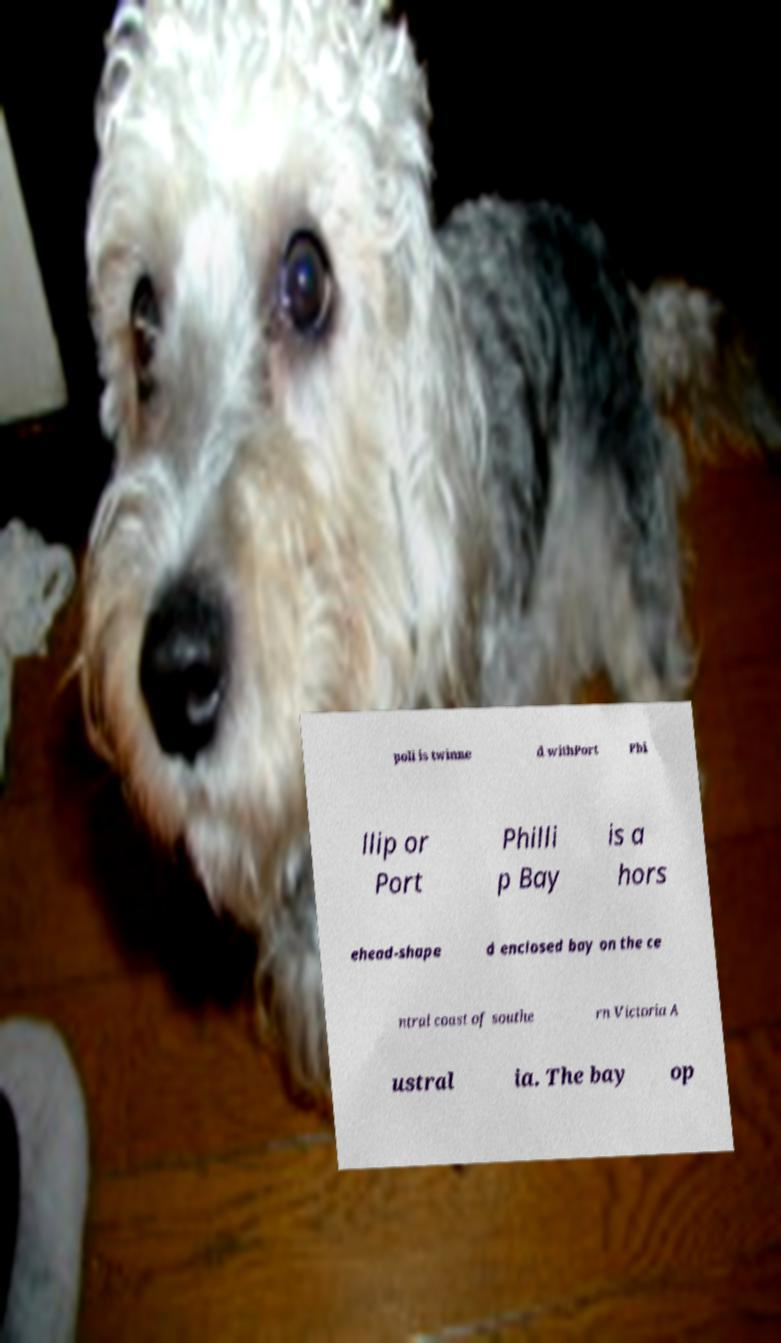What messages or text are displayed in this image? I need them in a readable, typed format. poli is twinne d withPort Phi llip or Port Philli p Bay is a hors ehead-shape d enclosed bay on the ce ntral coast of southe rn Victoria A ustral ia. The bay op 